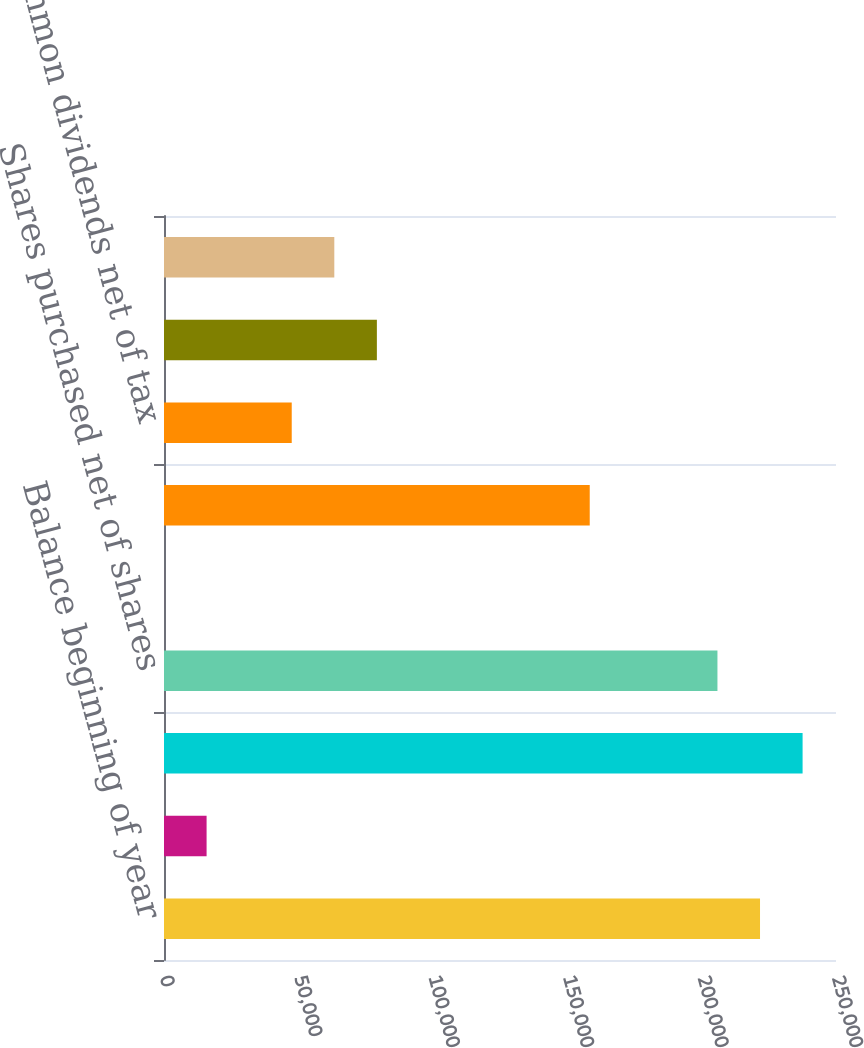<chart> <loc_0><loc_0><loc_500><loc_500><bar_chart><fcel>Balance beginning of year<fcel>Shares issued for stock<fcel>Balance end of year<fcel>Shares purchased net of shares<fcel>Tax benefit from option<fcel>Net earnings<fcel>Common dividends net of tax<fcel>Foreign currency translation<fcel>Change in minimum pension<nl><fcel>221733<fcel>15844.9<fcel>237571<fcel>205896<fcel>7.3<fcel>158383<fcel>47520<fcel>79195.1<fcel>63357.6<nl></chart> 